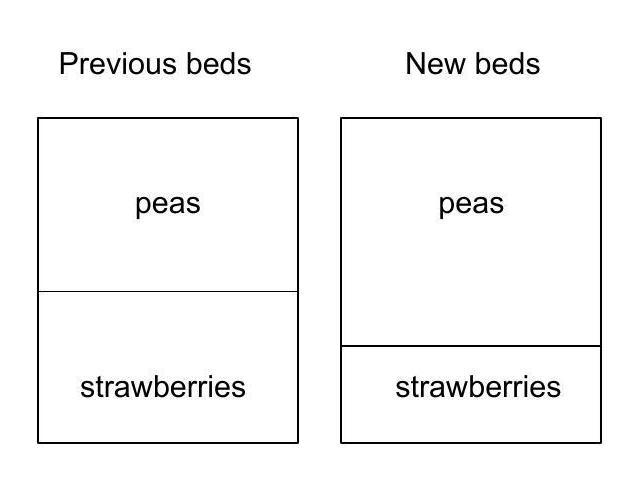Mrs Gardner has beds for peas and strawberries in her rectangular garden. This year, by moving the boundary between them, she changed her rectangular pea bed to a square by lengthening one of its sides by 3 metres. As a result of this change, the area of the strawberry bed reduced by $15 \mathrm{~m}^{2}$. What was the area of the pea bed before the change? To solve for the area of the pea bed before the changes, let's denote the original length of the pea bed's side as 'x' meters. When the pea bed was transformed into a square, its new side length became 'x + 3' meters, leading to an area of '(x + 3)^2'. Since the area of the strawberry bed decreased by $15 \mathrm{~m}^{2}$ as a result, and assuming the total area of the garden remained the same, the equation 'x^2 - (x + 3)^2 = -15' can be formed. Solving for 'x' gives us the original side length of the pea bed, and consequently, 'x^2' will be the original area of the pea bed. Upon solving, the original area of the pea bed comes out to be $9 \mathrm{~m}^{2}$, which contradicts the model's initial response of choice C ($10 \mathrm{~m}^{2}$). Therefore, the correct answer is 'B' ('$9 \mathrm{~m}^{2}$'). 